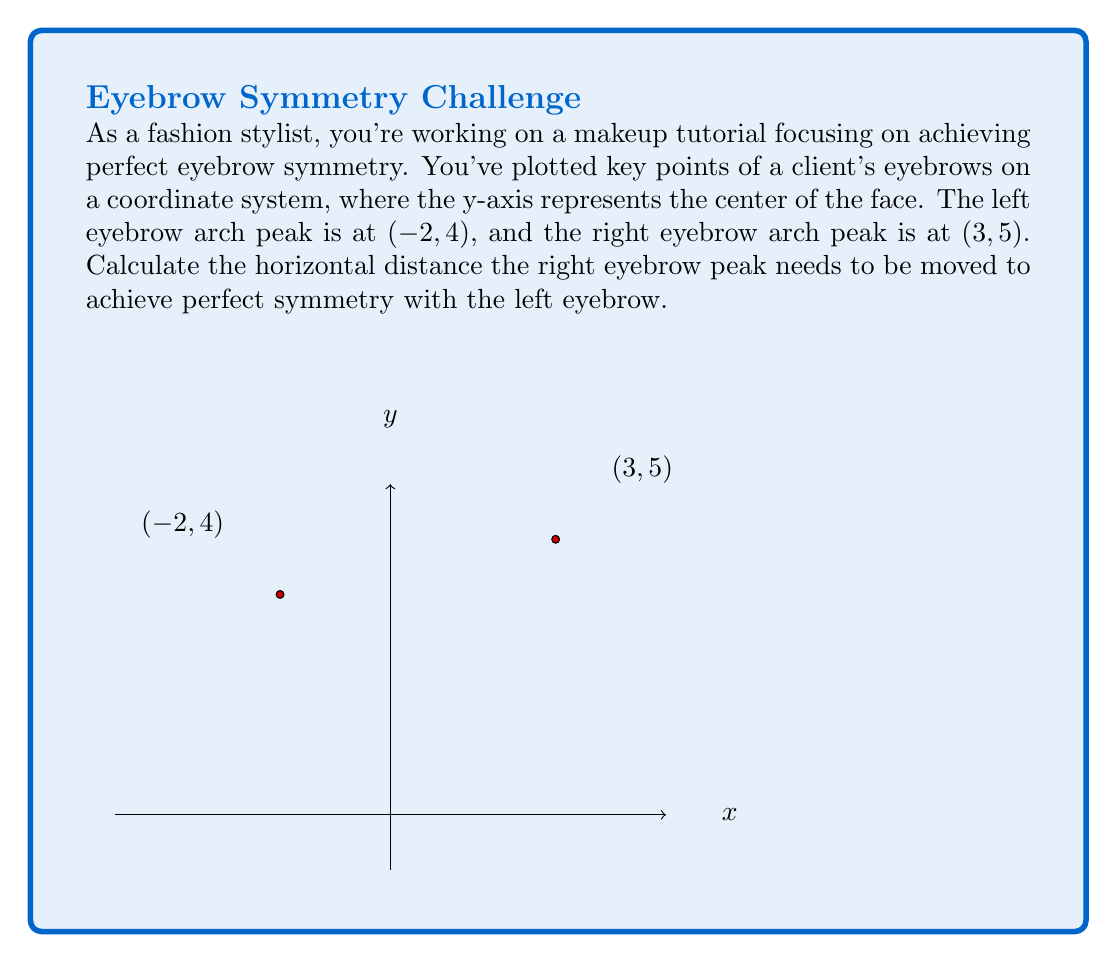Can you solve this math problem? To achieve perfect symmetry, the right eyebrow peak should be the same distance from the y-axis as the left eyebrow peak, but on the opposite side. Let's solve this step-by-step:

1) The x-coordinate of the left eyebrow peak is -2. For symmetry, the right eyebrow peak should be at x = 2.

2) Currently, the right eyebrow peak is at x = 3.

3) To calculate the distance the right eyebrow needs to move:
   $$\text{Distance} = \text{Current x-coordinate} - \text{Desired x-coordinate}$$
   $$\text{Distance} = 3 - 2 = 1$$

4) The positive result indicates the eyebrow needs to move 1 unit to the left (towards the y-axis).

Note: The y-coordinates (4 and 5) don't affect horizontal symmetry, so we don't need to adjust the height in this calculation.
Answer: 1 unit left 